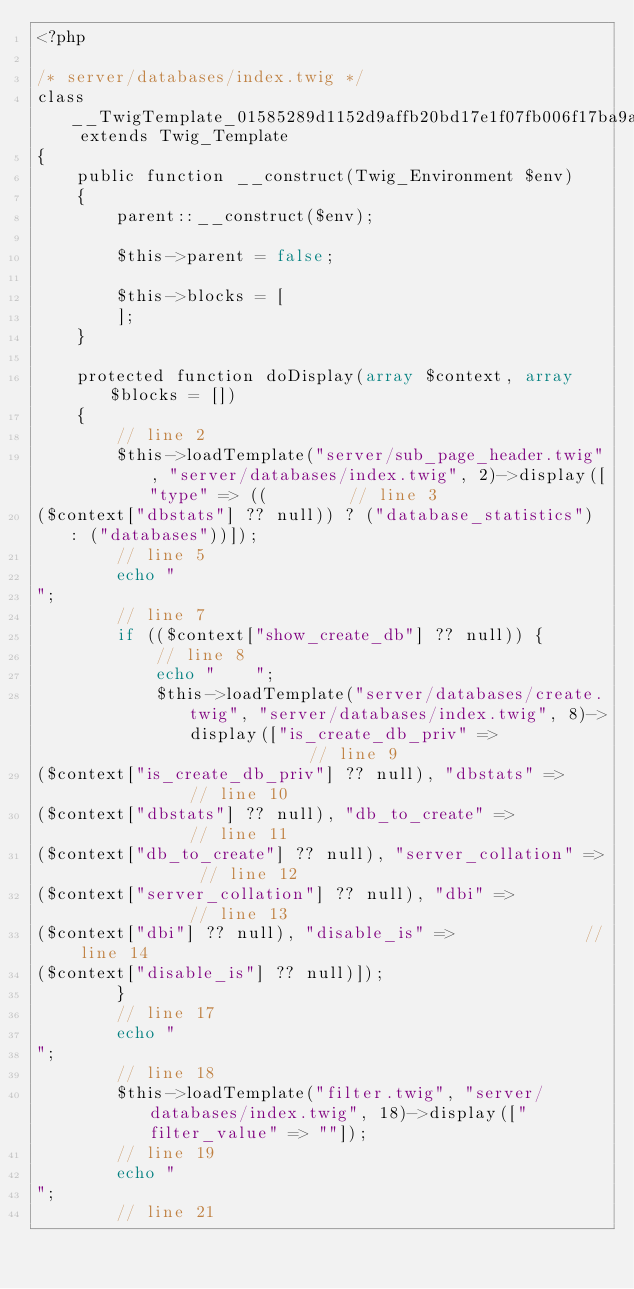<code> <loc_0><loc_0><loc_500><loc_500><_PHP_><?php

/* server/databases/index.twig */
class __TwigTemplate_01585289d1152d9affb20bd17e1f07fb006f17ba9ae161364b51bde50092d1d3 extends Twig_Template
{
    public function __construct(Twig_Environment $env)
    {
        parent::__construct($env);

        $this->parent = false;

        $this->blocks = [
        ];
    }

    protected function doDisplay(array $context, array $blocks = [])
    {
        // line 2
        $this->loadTemplate("server/sub_page_header.twig", "server/databases/index.twig", 2)->display(["type" => ((        // line 3
($context["dbstats"] ?? null)) ? ("database_statistics") : ("databases"))]);
        // line 5
        echo "
";
        // line 7
        if (($context["show_create_db"] ?? null)) {
            // line 8
            echo "    ";
            $this->loadTemplate("server/databases/create.twig", "server/databases/index.twig", 8)->display(["is_create_db_priv" =>             // line 9
($context["is_create_db_priv"] ?? null), "dbstats" =>             // line 10
($context["dbstats"] ?? null), "db_to_create" =>             // line 11
($context["db_to_create"] ?? null), "server_collation" =>             // line 12
($context["server_collation"] ?? null), "dbi" =>             // line 13
($context["dbi"] ?? null), "disable_is" =>             // line 14
($context["disable_is"] ?? null)]);
        }
        // line 17
        echo "
";
        // line 18
        $this->loadTemplate("filter.twig", "server/databases/index.twig", 18)->display(["filter_value" => ""]);
        // line 19
        echo "
";
        // line 21</code> 